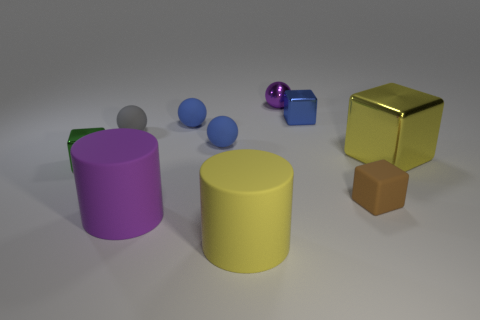How many objects are there in the image, and can you describe their colors? There are seven objects in the image including two cylinders, one cube, three spheres, and one object that resembles a cube with a portion cut off. The colors are purple, yellow, blue, gold, gray, and brown. 